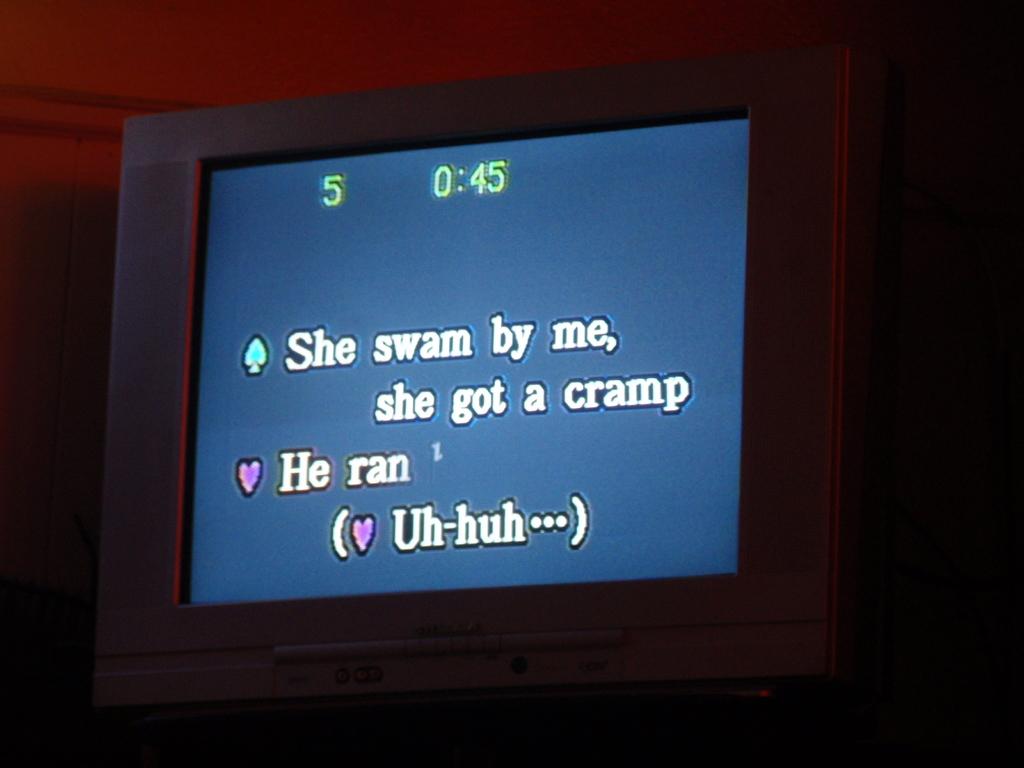She swam by who?
Offer a very short reply. Me. What did she get?
Provide a succinct answer. A cramp. 